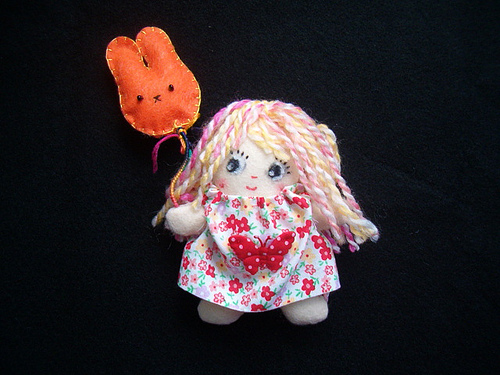<image>
Is the balloon bunny in front of the girl? No. The balloon bunny is not in front of the girl. The spatial positioning shows a different relationship between these objects. 